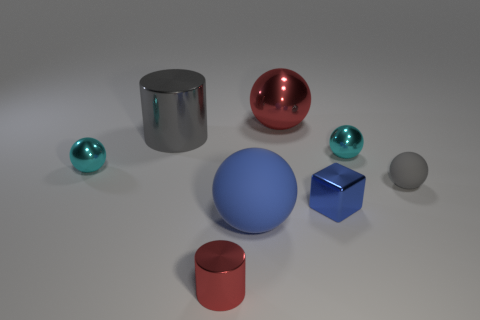Subtract all small gray balls. How many balls are left? 4 Subtract all yellow cylinders. Subtract all yellow cubes. How many cylinders are left? 2 Add 2 large yellow things. How many objects exist? 10 Subtract all cylinders. How many objects are left? 6 Subtract all tiny brown cylinders. Subtract all cyan shiny things. How many objects are left? 6 Add 6 blue matte things. How many blue matte things are left? 7 Add 1 green metal objects. How many green metal objects exist? 1 Subtract 0 purple blocks. How many objects are left? 8 